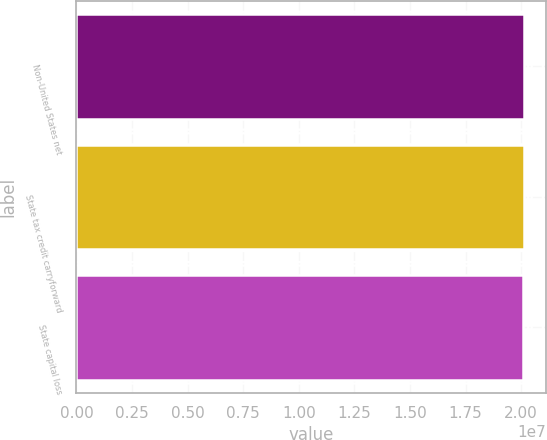<chart> <loc_0><loc_0><loc_500><loc_500><bar_chart><fcel>Non-United States net<fcel>State tax credit carryforward<fcel>State capital loss<nl><fcel>2.0112e+07<fcel>2.0114e+07<fcel>2.0092e+07<nl></chart> 